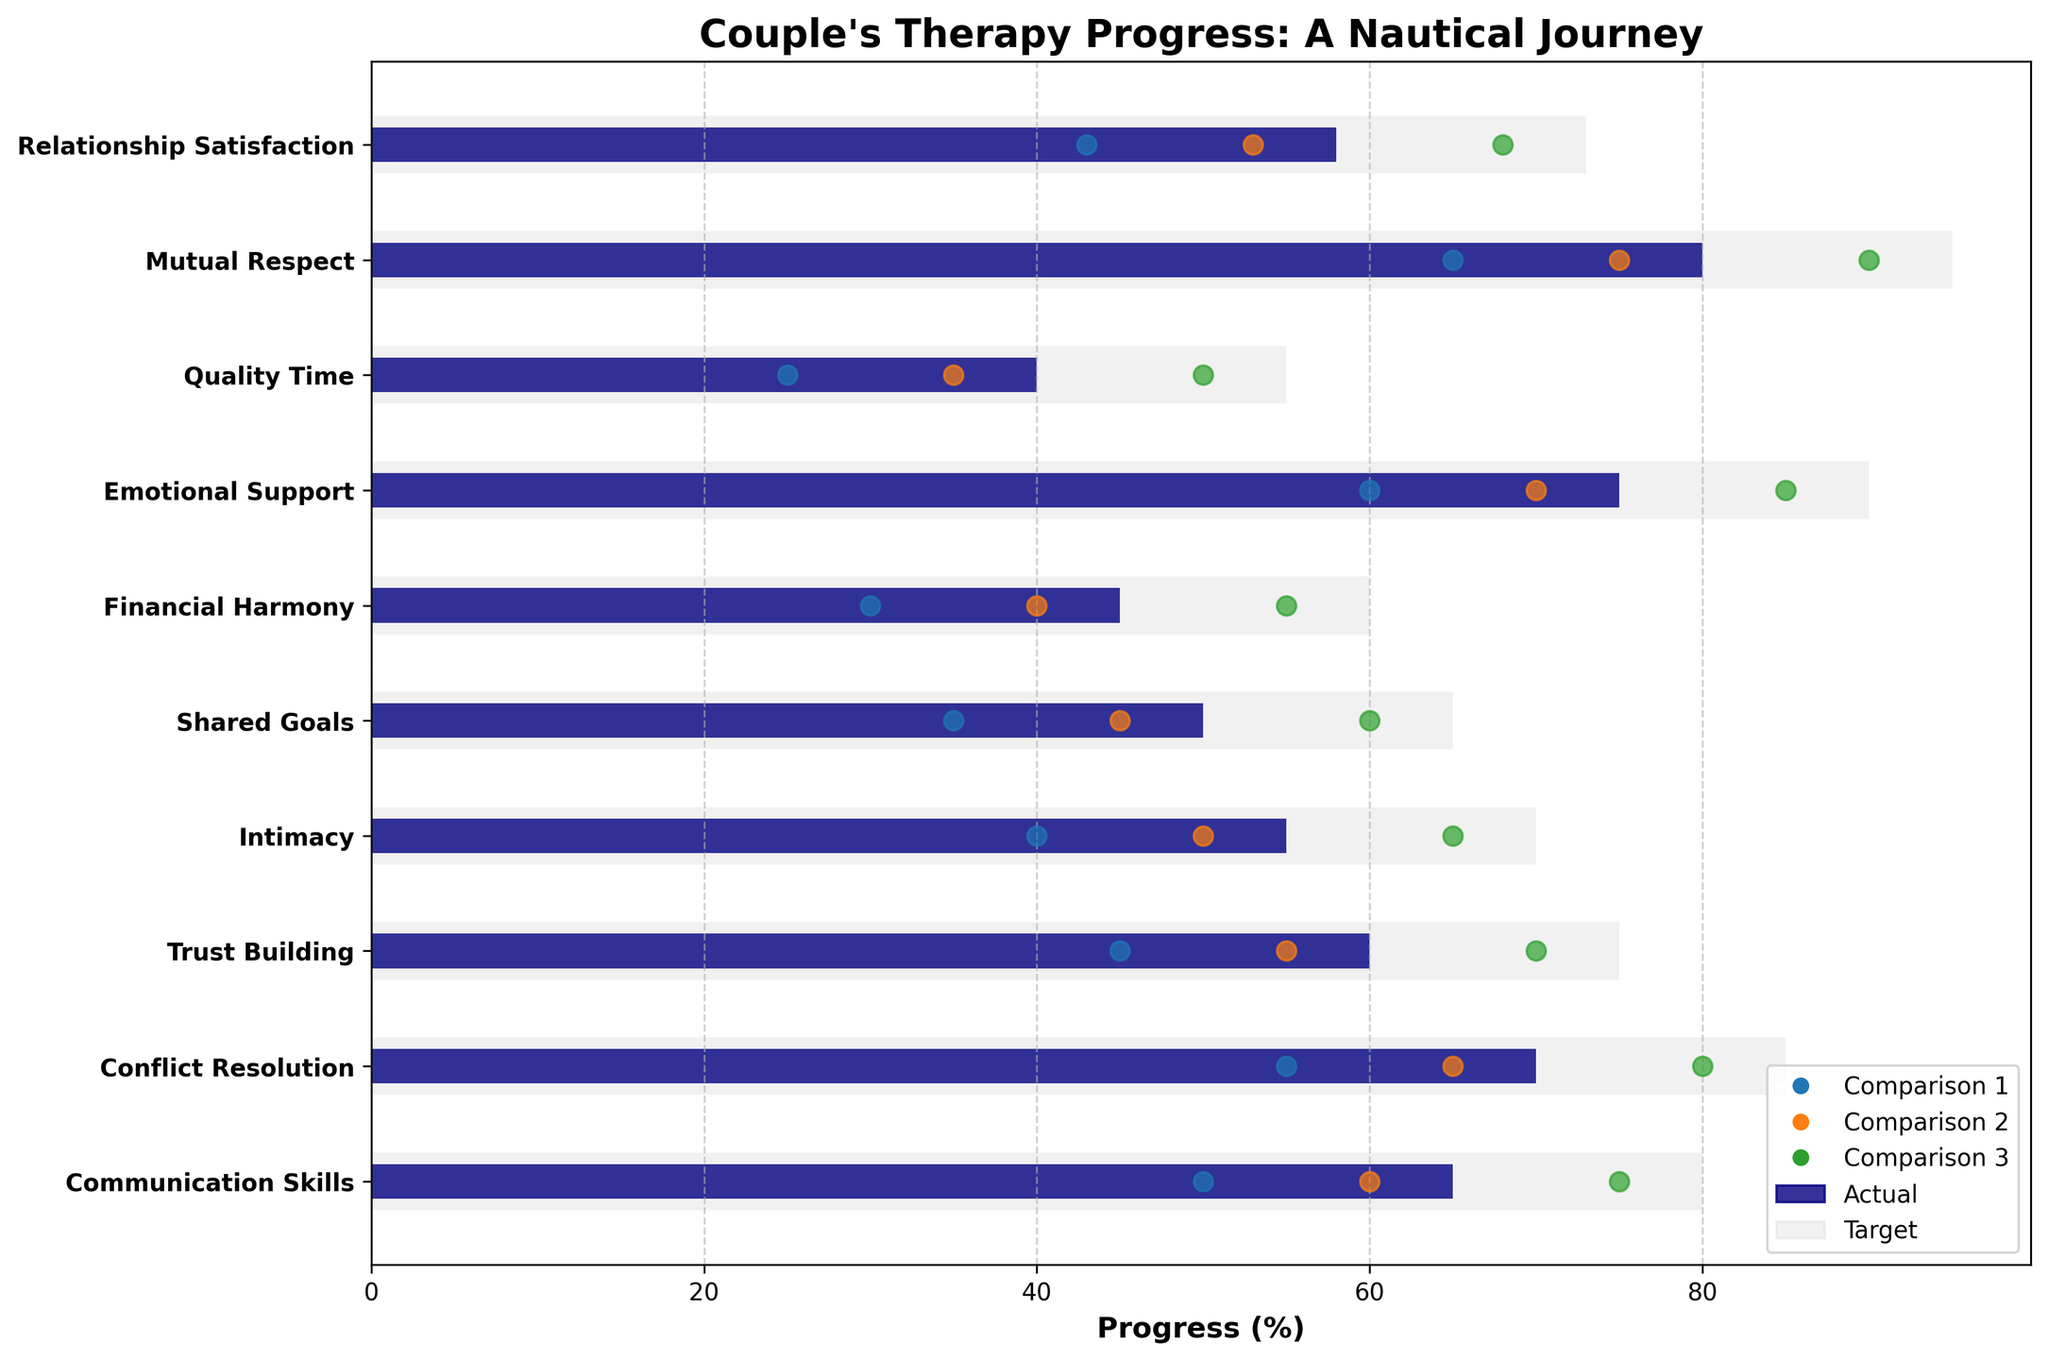What is the title of the chart? The title is located at the top of the chart. It reads "Couple's Therapy Progress: A Nautical Journey".
Answer: Couple's Therapy Progress: A Nautical Journey What does the bar in light grey represent? The light grey bars represent the target values for each category.
Answer: Target values Which category has the highest actual progress percentage? By looking at the navy bars which represent actual values, the category with the longest navy bar corresponds to "Mutual Respect" which is at 80%.
Answer: Mutual Respect How many categories are being tracked in this chart? Count the number of categories listed on the y-axis of the chart. There are 10 categories in total.
Answer: 10 What is the target percentage for the category "Quality Time"? Look at the length of the light grey bar corresponding to the "Quality Time" label. The target percentage for Quality Time is 55%.
Answer: 55% Which category has the greatest gap between the actual progress and the target? Calculate the difference between the actual percentage (navy bar) and the target percentage (light grey bar) for each category. The largest difference is for "Emotional Support" with a gap of 15% (90 - 75).
Answer: Emotional Support Compare the actual progress of "Trust Building" with "Financial Harmony". Which is higher and by how much? The actual progress for "Trust Building" is 60%, while for "Financial Harmony" it is 45%. The difference is 60 - 45 = 15%.
Answer: Trust Building by 15% Which comparisons are closest to the actual progress in terms of percentage for "Conflict Resolution"? Look at the comparison markers (dots) for "Conflict Resolution". Comparison 2 (65%) is closest to the actual progress (70%).
Answer: Comparison 2 What can be inferred about the shared goals compared to the nautical journey? The shared goals category has an actual progress of 50%, which is approximately the same as the first comparison (35%), significantly lagging behind the second and third comparisons (45% and 60%) indicating more improvements are needed compared to other nautical journey stages.
Answer: Lagging behind What is the pattern of improvement suggested by the comparison markers for "Intimacy"? The markers for "Intimacy" (40%, 50%, 65%) suggest a gradual improvement in stages, aligning with the progressive approach of navigating through stages in a nautical journey.
Answer: Gradual improvement 